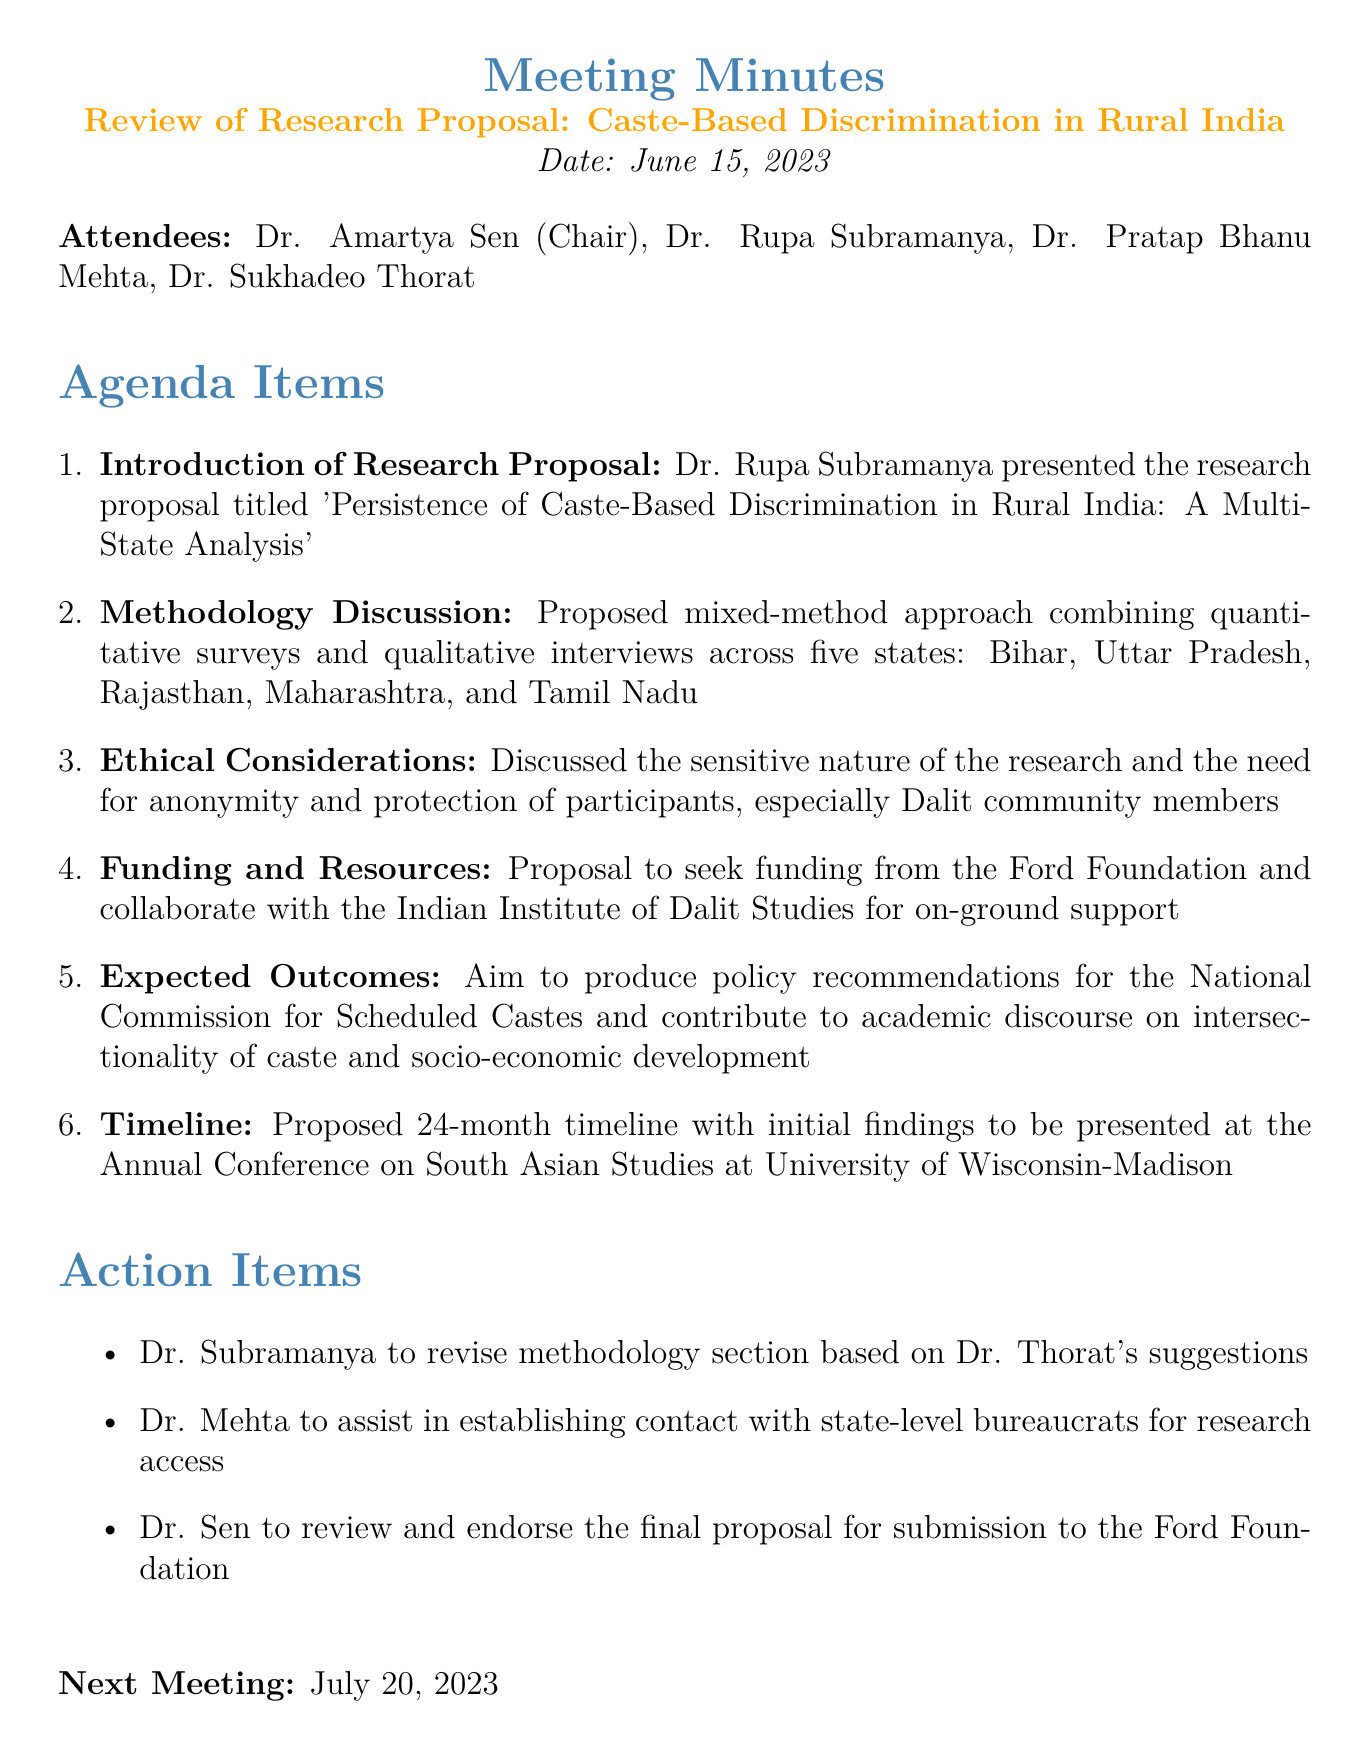what is the title of the research proposal? The title of the research proposal is mentioned by Dr. Rupa Subramanya during the introduction, which is 'Persistence of Caste-Based Discrimination in Rural India: A Multi-State Analysis'.
Answer: Persistence of Caste-Based Discrimination in Rural India: A Multi-State Analysis who presented the research proposal? The document states that Dr. Rupa Subramanya presented the research proposal.
Answer: Dr. Rupa Subramanya how many states are included in the research methodology? The methodology discussion indicates that the research will cover five states.
Answer: five which organization is proposed for funding? The document mentions seeking funding from the Ford Foundation for the research project.
Answer: Ford Foundation what is the proposed duration of the research? The timeline section notes a proposed duration of 24 months for the research project.
Answer: 24 months what are the expected outcomes of the research? The expected outcomes include producing policy recommendations for the National Commission for Scheduled Castes and contributing to academic discourse.
Answer: Policy recommendations for the National Commission for Scheduled Castes who is the chair of the meeting? The meeting minutes list Dr. Amartya Sen as the chair of the meeting.
Answer: Dr. Amartya Sen when is the next meeting scheduled? The last line of the document states that the next meeting is scheduled for July 20, 2023.
Answer: July 20, 2023 what is the main ethical consideration discussed? The document highlights the need for anonymity and protection of participants in the research, particularly for Dalit community members.
Answer: Anonymity and protection of participants 